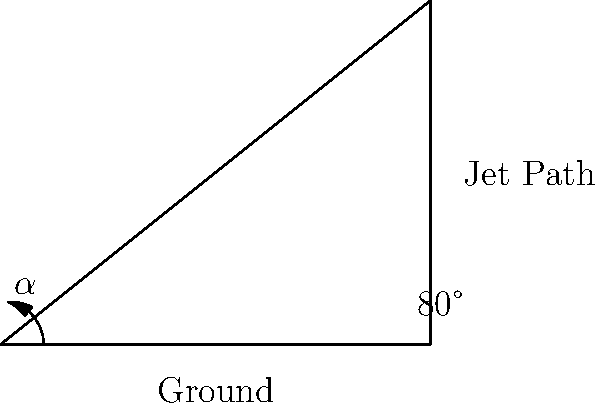During a steep climb maneuver, a Thunderbird jet's flight path makes an 80° angle with the ground. If the jet's body is aligned with its flight path, what is the angle of attack ($\alpha$) relative to the ground? To solve this problem, we need to understand the concept of angle of attack and its relation to the aircraft's orientation:

1. The angle of attack is typically measured between the aircraft's body (chord line) and the relative wind.
2. In this case, we're asked about the angle relative to the ground, which is effectively the complement of the climb angle.
3. The climb angle is given as 80°.
4. To find the angle of attack relative to the ground, we need to subtract the climb angle from 90°:

   $\alpha = 90° - 80°$

5. Calculating:
   $\alpha = 10°$

This means the Thunderbird jet's body is at a 10° angle relative to the ground during this steep climb maneuver.
Answer: $10°$ 